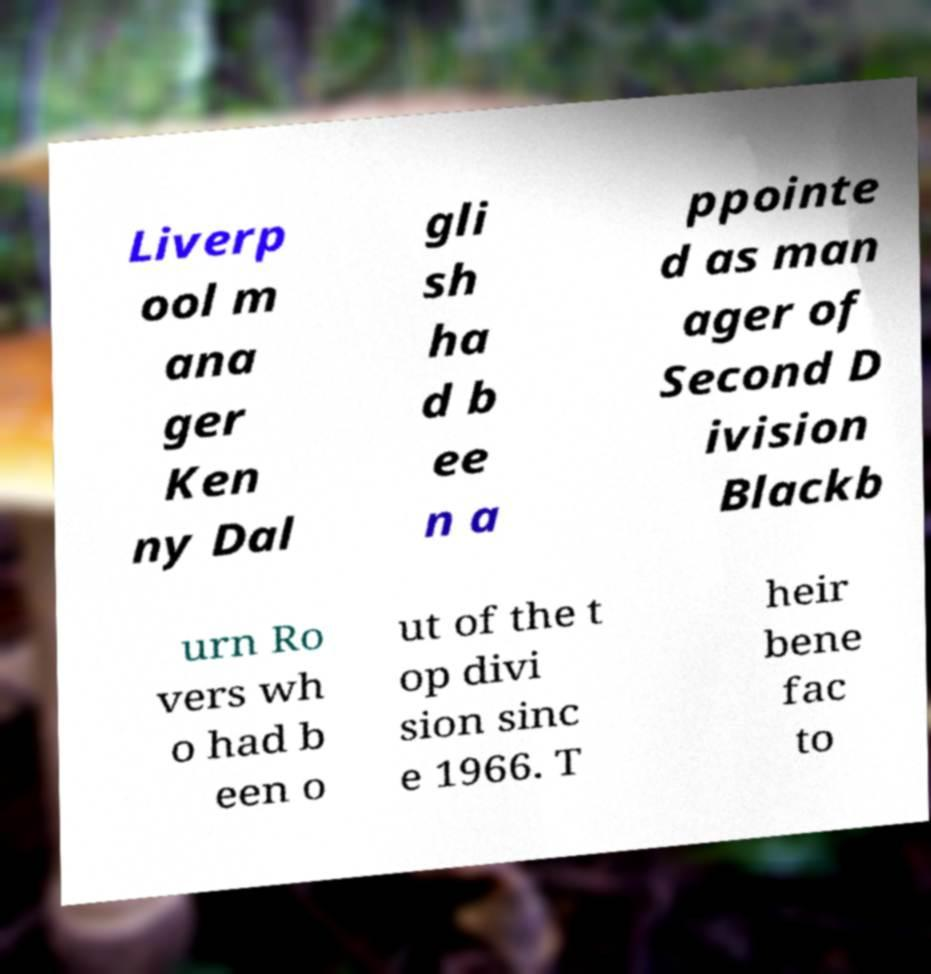Please identify and transcribe the text found in this image. Liverp ool m ana ger Ken ny Dal gli sh ha d b ee n a ppointe d as man ager of Second D ivision Blackb urn Ro vers wh o had b een o ut of the t op divi sion sinc e 1966. T heir bene fac to 